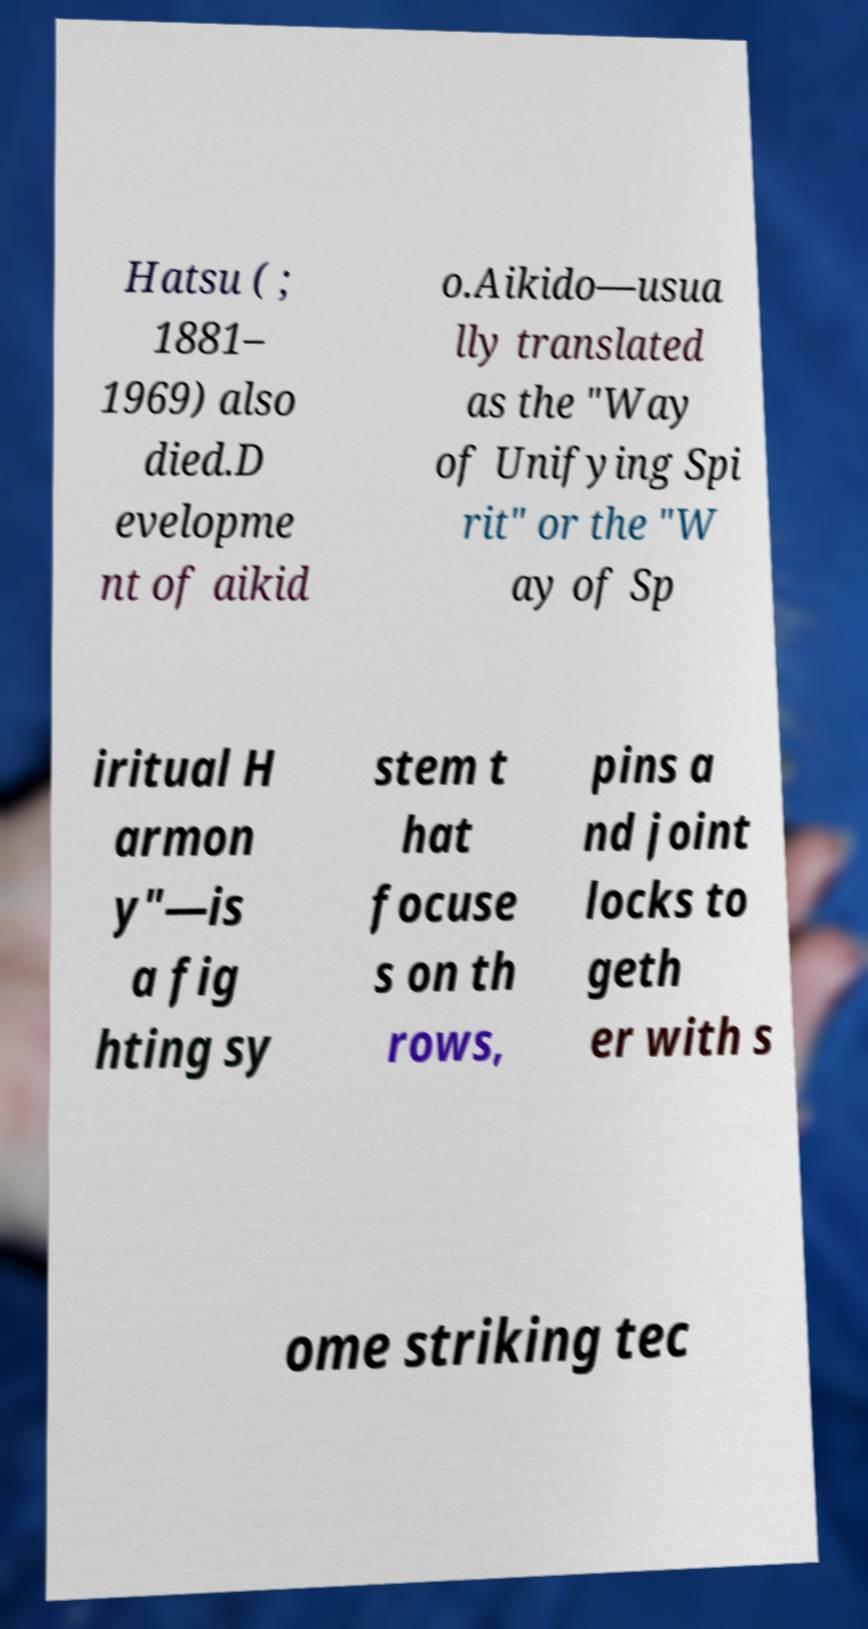What messages or text are displayed in this image? I need them in a readable, typed format. Hatsu ( ; 1881– 1969) also died.D evelopme nt of aikid o.Aikido—usua lly translated as the "Way of Unifying Spi rit" or the "W ay of Sp iritual H armon y"—is a fig hting sy stem t hat focuse s on th rows, pins a nd joint locks to geth er with s ome striking tec 